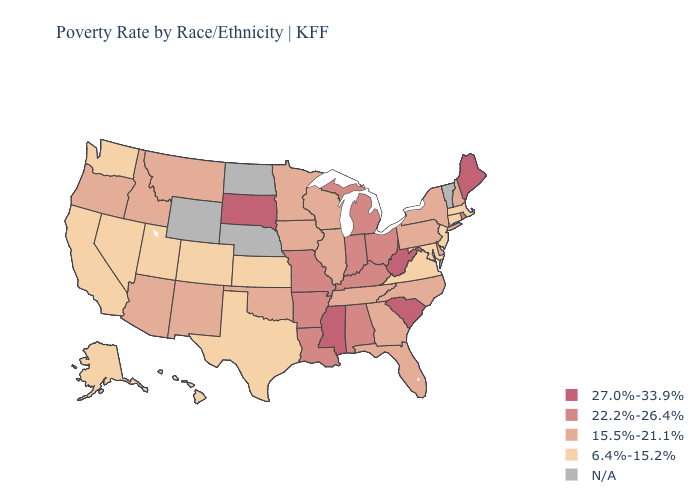Does the first symbol in the legend represent the smallest category?
Short answer required. No. What is the lowest value in the MidWest?
Quick response, please. 6.4%-15.2%. What is the value of Arizona?
Quick response, please. 15.5%-21.1%. Name the states that have a value in the range N/A?
Write a very short answer. Nebraska, North Dakota, Vermont, Wyoming. Which states have the lowest value in the West?
Concise answer only. Alaska, California, Colorado, Hawaii, Nevada, Utah, Washington. Name the states that have a value in the range 27.0%-33.9%?
Concise answer only. Maine, Mississippi, South Carolina, South Dakota, West Virginia. What is the lowest value in the USA?
Short answer required. 6.4%-15.2%. What is the value of North Dakota?
Write a very short answer. N/A. What is the value of Massachusetts?
Concise answer only. 6.4%-15.2%. Among the states that border Pennsylvania , which have the highest value?
Quick response, please. West Virginia. Name the states that have a value in the range N/A?
Keep it brief. Nebraska, North Dakota, Vermont, Wyoming. What is the value of Kentucky?
Short answer required. 22.2%-26.4%. 